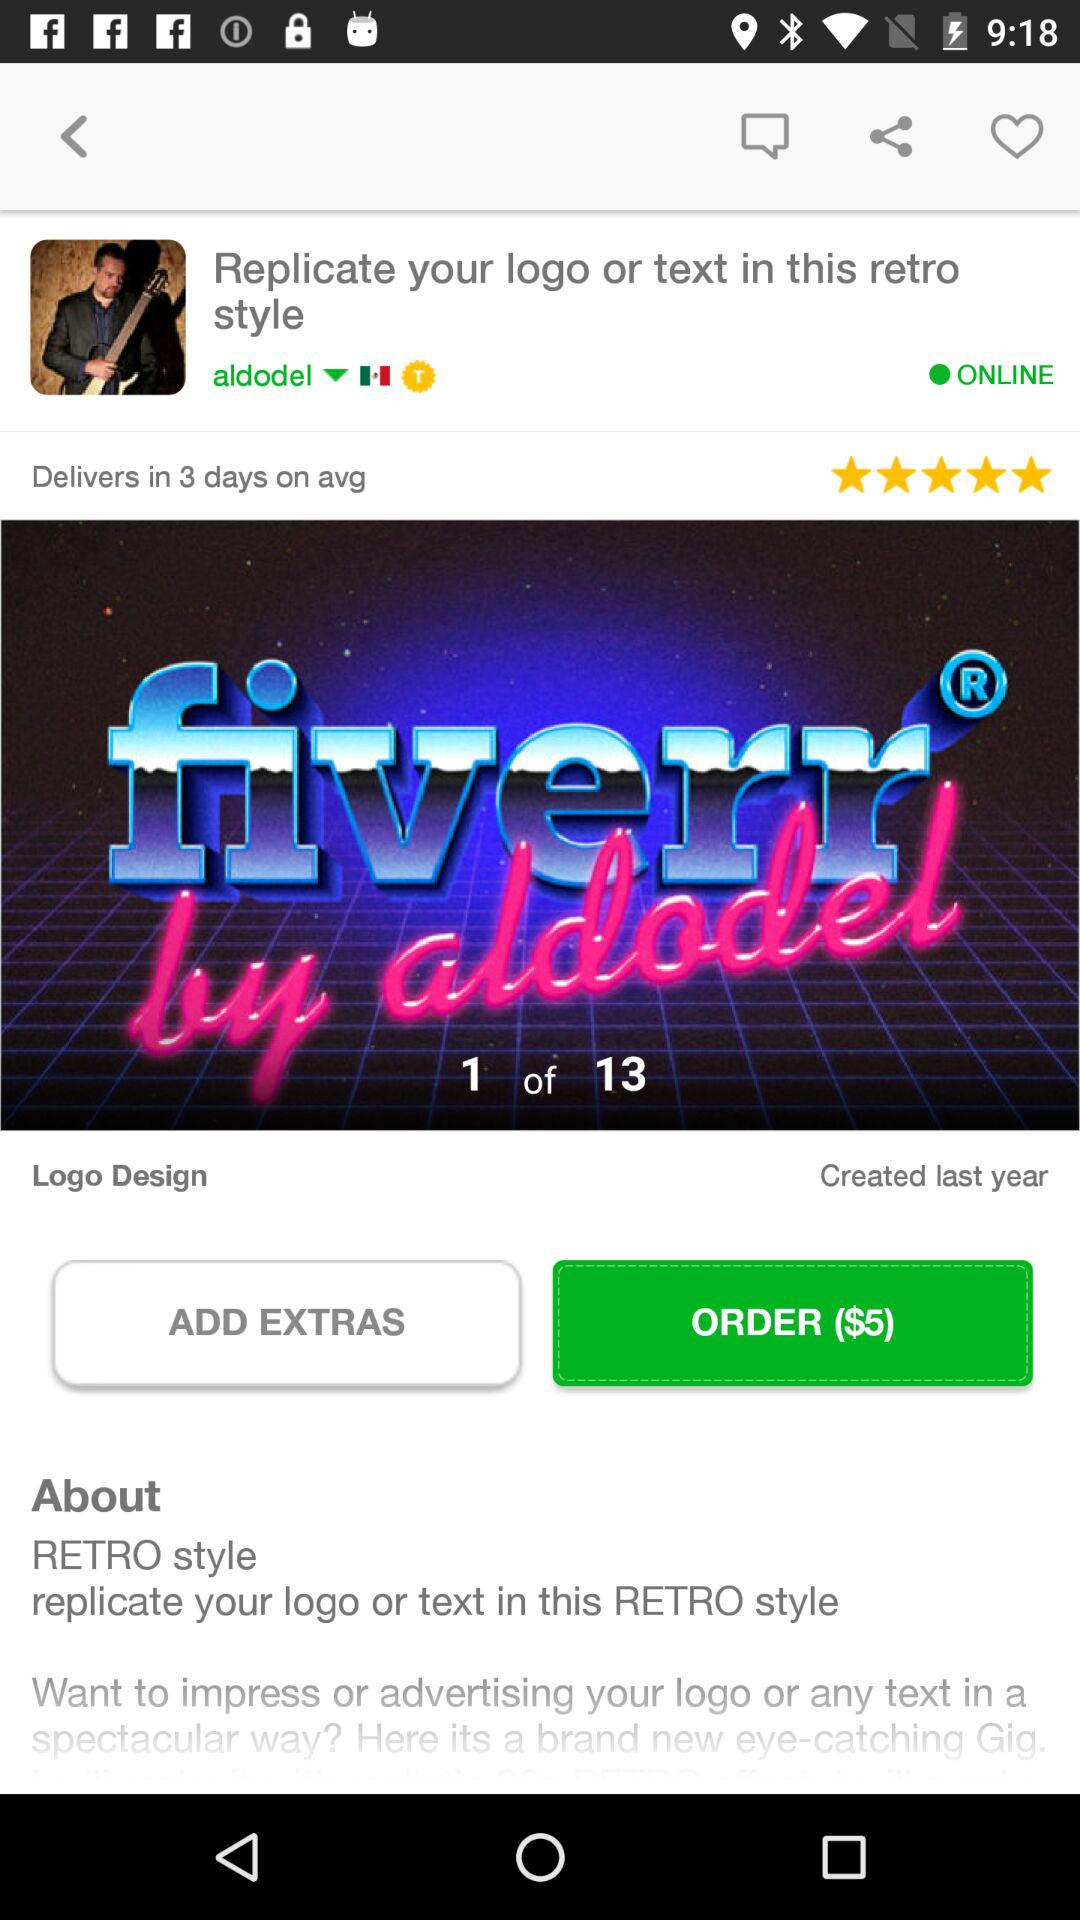What is the active status of the user? The user is online. 